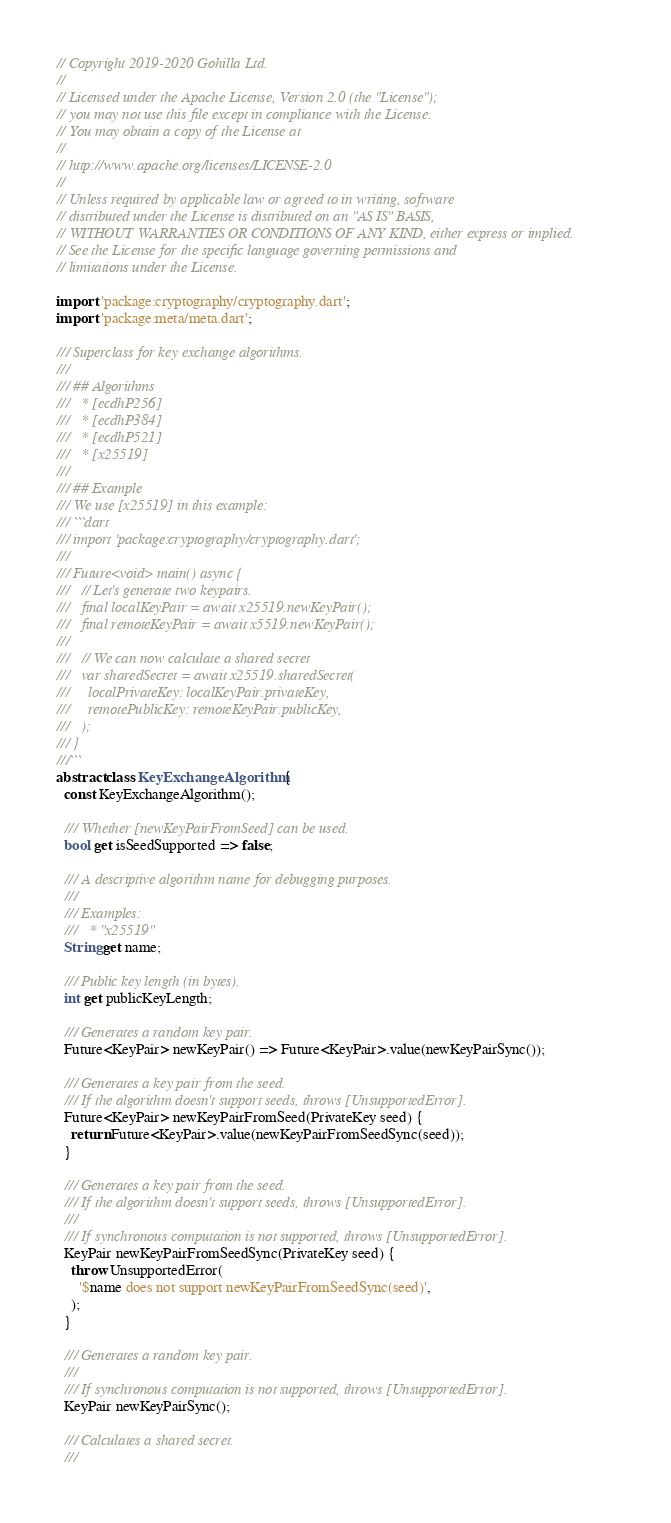<code> <loc_0><loc_0><loc_500><loc_500><_Dart_>// Copyright 2019-2020 Gohilla Ltd.
//
// Licensed under the Apache License, Version 2.0 (the "License");
// you may not use this file except in compliance with the License.
// You may obtain a copy of the License at
//
// http://www.apache.org/licenses/LICENSE-2.0
//
// Unless required by applicable law or agreed to in writing, software
// distributed under the License is distributed on an "AS IS" BASIS,
// WITHOUT WARRANTIES OR CONDITIONS OF ANY KIND, either express or implied.
// See the License for the specific language governing permissions and
// limitations under the License.

import 'package:cryptography/cryptography.dart';
import 'package:meta/meta.dart';

/// Superclass for key exchange algorithms.
///
/// ## Algorithms
///   * [ecdhP256]
///   * [ecdhP384]
///   * [ecdhP521]
///   * [x25519]
///
/// ## Example
/// We use [x25519] in this example:
/// ```dart
/// import 'package:cryptography/cryptography.dart';
///
/// Future<void> main() async {
///   // Let's generate two keypairs.
///   final localKeyPair = await x25519.newKeyPair();
///   final remoteKeyPair = await x5519.newKeyPair();
///
///   // We can now calculate a shared secret
///   var sharedSecret = await x25519.sharedSecret(
///     localPrivateKey: localKeyPair.privateKey,
///     remotePublicKey: remoteKeyPair.publicKey,
///   );
/// }
///```
abstract class KeyExchangeAlgorithm {
  const KeyExchangeAlgorithm();

  /// Whether [newKeyPairFromSeed] can be used.
  bool get isSeedSupported => false;

  /// A descriptive algorithm name for debugging purposes.
  ///
  /// Examples:
  ///   * "x25519"
  String get name;

  /// Public key length (in bytes).
  int get publicKeyLength;

  /// Generates a random key pair.
  Future<KeyPair> newKeyPair() => Future<KeyPair>.value(newKeyPairSync());

  /// Generates a key pair from the seed.
  /// If the algorithm doesn't support seeds, throws [UnsupportedError].
  Future<KeyPair> newKeyPairFromSeed(PrivateKey seed) {
    return Future<KeyPair>.value(newKeyPairFromSeedSync(seed));
  }

  /// Generates a key pair from the seed.
  /// If the algorithm doesn't support seeds, throws [UnsupportedError].
  ///
  /// If synchronous computation is not supported, throws [UnsupportedError].
  KeyPair newKeyPairFromSeedSync(PrivateKey seed) {
    throw UnsupportedError(
      '$name does not support newKeyPairFromSeedSync(seed)',
    );
  }

  /// Generates a random key pair.
  ///
  /// If synchronous computation is not supported, throws [UnsupportedError].
  KeyPair newKeyPairSync();

  /// Calculates a shared secret.
  ///</code> 